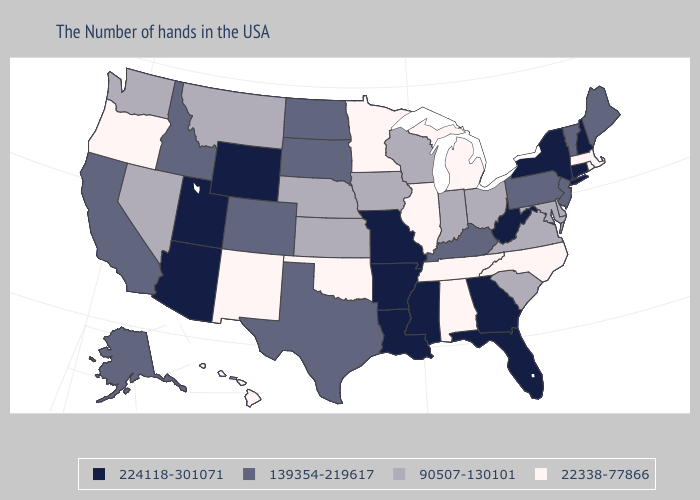Name the states that have a value in the range 90507-130101?
Answer briefly. Delaware, Maryland, Virginia, South Carolina, Ohio, Indiana, Wisconsin, Iowa, Kansas, Nebraska, Montana, Nevada, Washington. Name the states that have a value in the range 224118-301071?
Concise answer only. New Hampshire, Connecticut, New York, West Virginia, Florida, Georgia, Mississippi, Louisiana, Missouri, Arkansas, Wyoming, Utah, Arizona. What is the highest value in the USA?
Short answer required. 224118-301071. Does Alabama have the same value as Oregon?
Write a very short answer. Yes. What is the lowest value in the USA?
Quick response, please. 22338-77866. What is the value of New York?
Write a very short answer. 224118-301071. What is the value of Delaware?
Write a very short answer. 90507-130101. Does the map have missing data?
Give a very brief answer. No. Name the states that have a value in the range 90507-130101?
Keep it brief. Delaware, Maryland, Virginia, South Carolina, Ohio, Indiana, Wisconsin, Iowa, Kansas, Nebraska, Montana, Nevada, Washington. What is the value of Wisconsin?
Answer briefly. 90507-130101. Which states have the lowest value in the USA?
Answer briefly. Massachusetts, Rhode Island, North Carolina, Michigan, Alabama, Tennessee, Illinois, Minnesota, Oklahoma, New Mexico, Oregon, Hawaii. What is the value of Kentucky?
Quick response, please. 139354-219617. Among the states that border Nevada , which have the highest value?
Be succinct. Utah, Arizona. Does New Hampshire have the highest value in the Northeast?
Be succinct. Yes. 